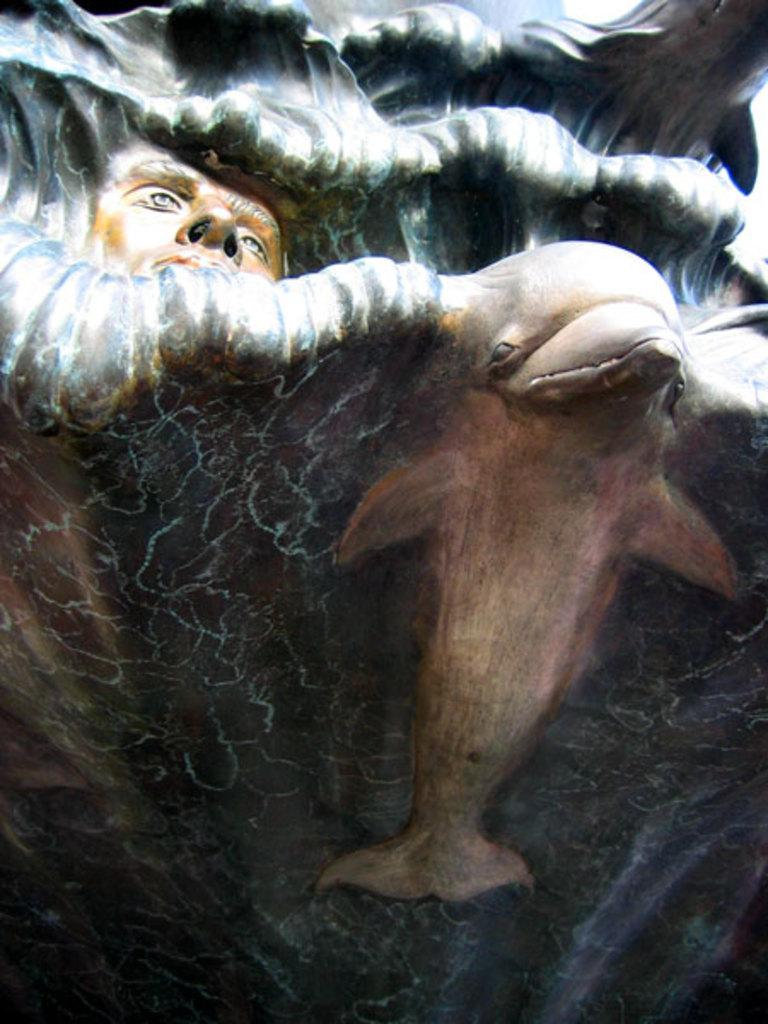What is the main subject of the image? There is a painting in the image. What type of grain is being advertised in the painting? There is no grain or advertisement present in the painting; it is a standalone artwork. 